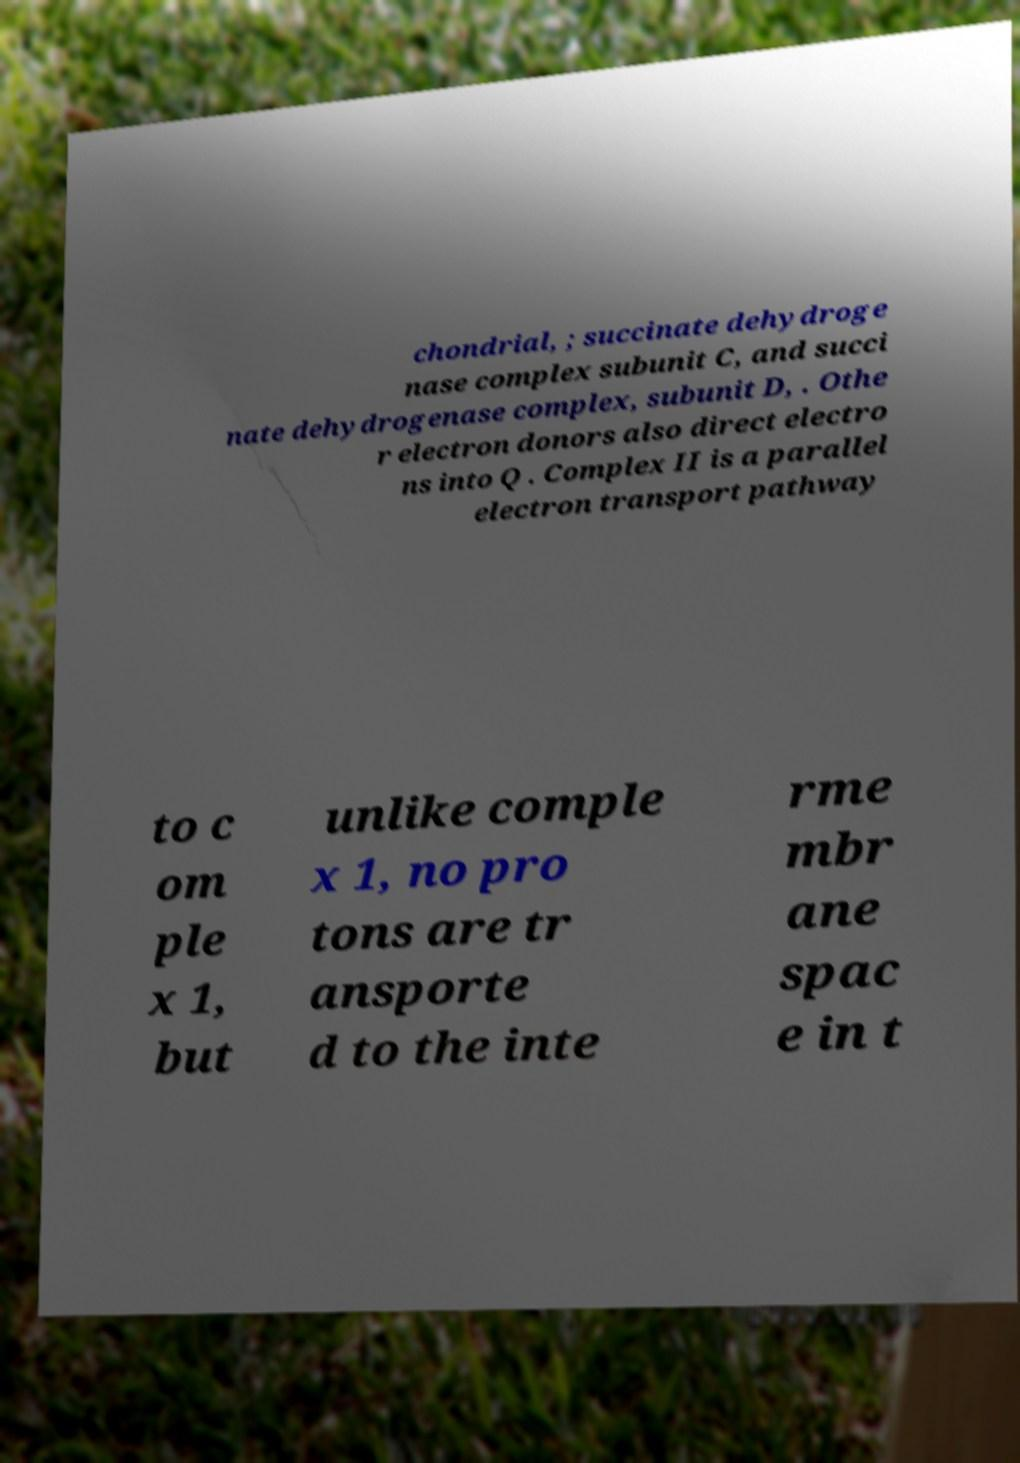Could you assist in decoding the text presented in this image and type it out clearly? chondrial, ; succinate dehydroge nase complex subunit C, and succi nate dehydrogenase complex, subunit D, . Othe r electron donors also direct electro ns into Q . Complex II is a parallel electron transport pathway to c om ple x 1, but unlike comple x 1, no pro tons are tr ansporte d to the inte rme mbr ane spac e in t 